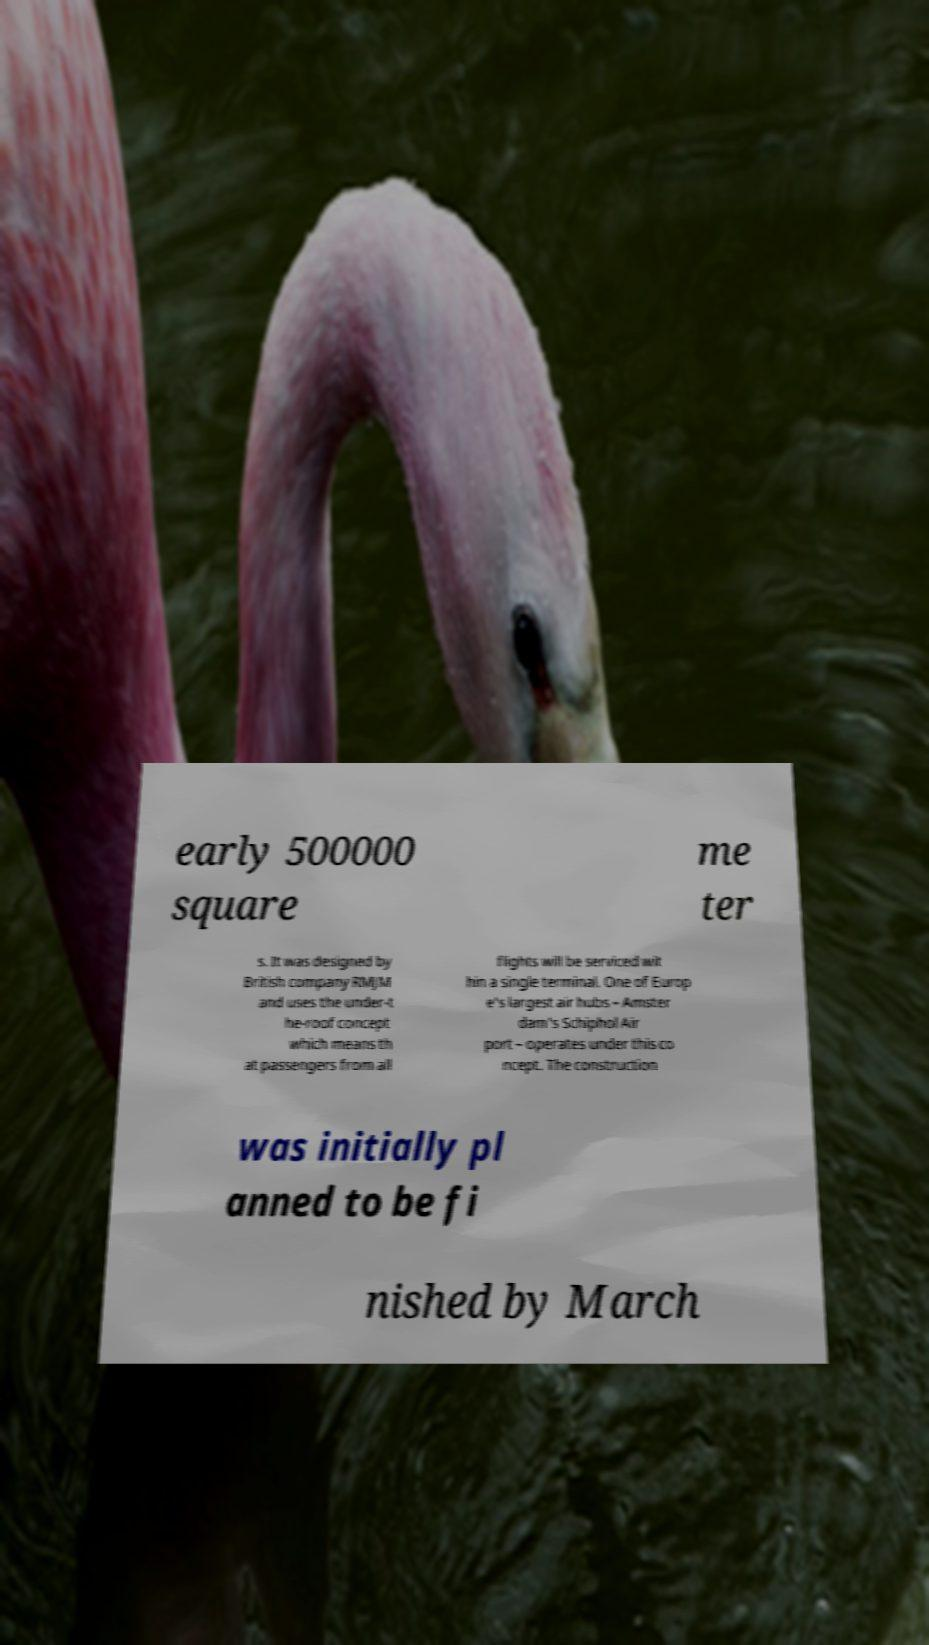Can you read and provide the text displayed in the image?This photo seems to have some interesting text. Can you extract and type it out for me? early 500000 square me ter s. It was designed by British company RMJM and uses the under-t he-roof concept which means th at passengers from all flights will be serviced wit hin a single terminal. One of Europ e's largest air hubs – Amster dam's Schiphol Air port – operates under this co ncept. The construction was initially pl anned to be fi nished by March 